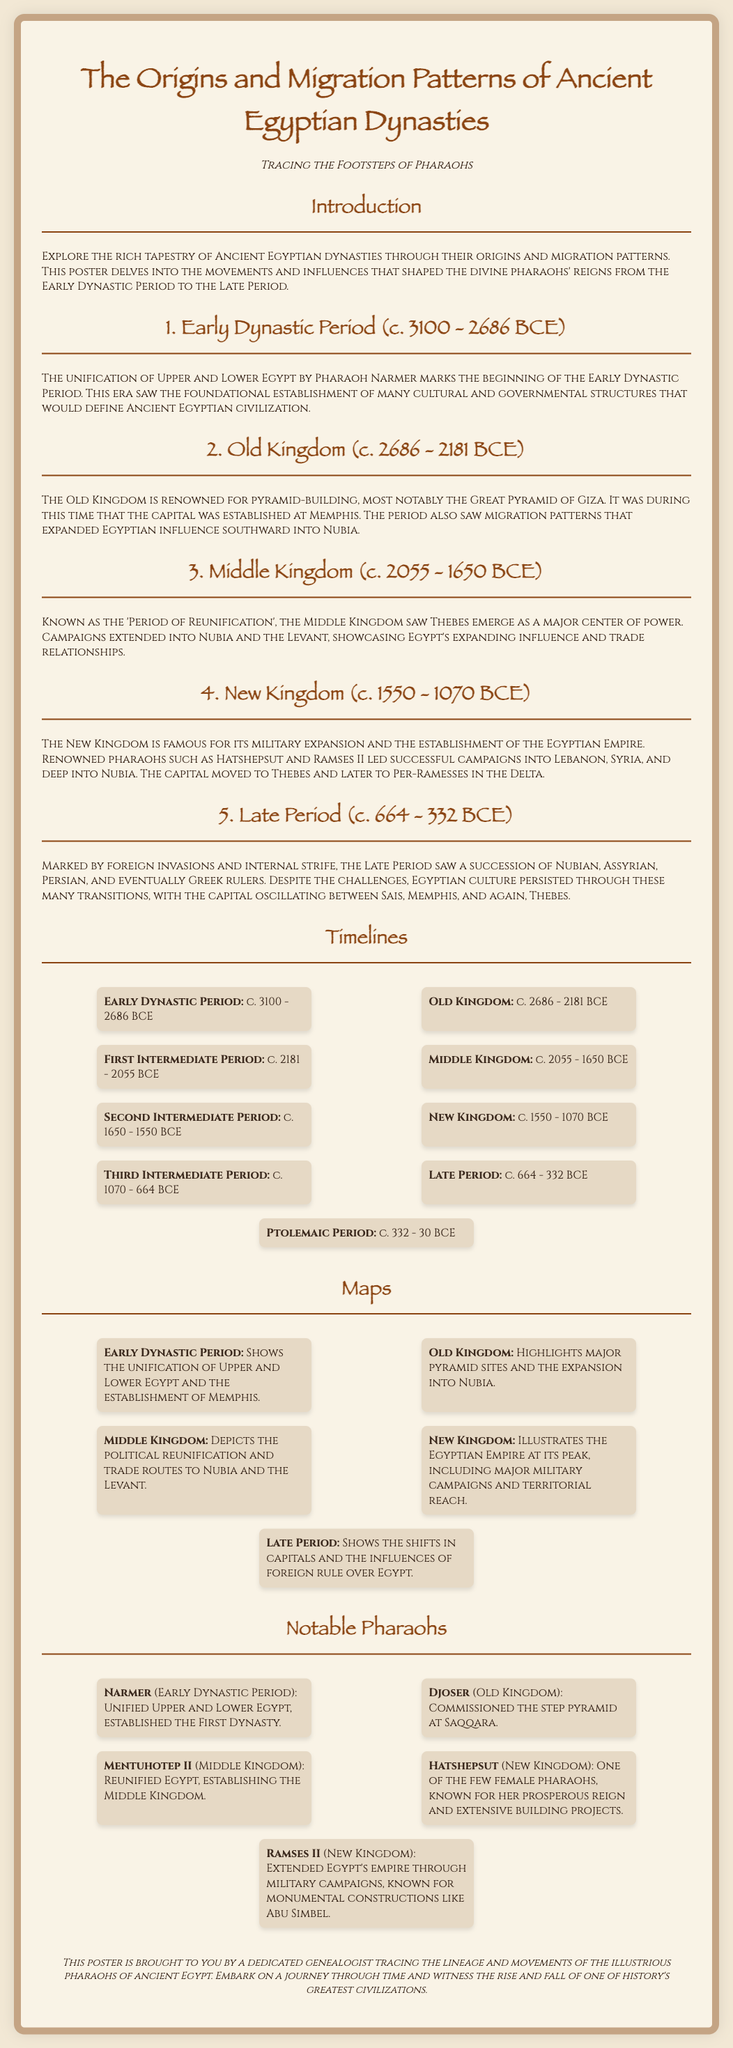What period did Narmer unify Upper and Lower Egypt? Narmer unified Upper and Lower Egypt at the beginning of the Early Dynastic Period.
Answer: Early Dynastic Period What is the capital during the Old Kingdom? The capital of Egypt was established at Memphis during the Old Kingdom.
Answer: Memphis Which pharaoh commissioned the step pyramid? Djoser is known for commissioning the step pyramid at Saqqara.
Answer: Djoser Which period is known as the 'Period of Reunification'? The Middle Kingdom is referred to as the 'Period of Reunification'.
Answer: Middle Kingdom What are the dates of the New Kingdom? The New Kingdom lasted from 1550 to 1070 BCE.
Answer: c. 1550 - 1070 BCE Which pharaoh led campaigns into Lebanon and Syria? Hatshepsut is recognized for her military campaigns into Lebanon and Syria.
Answer: Hatshepsut What influences are noted during the Late Period? The Late Period was marked by foreign invasions, including Nubian, Assyrian, Persian, and Greek rulers.
Answer: Foreign invasions What major structure is associated with the pharaoh Ramses II? Ramses II is known for monumental constructions like Abu Simbel.
Answer: Abu Simbel In which kingdom did Thebes emerge as a major center of power? Thebes became a significant political center during the Middle Kingdom.
Answer: Middle Kingdom 